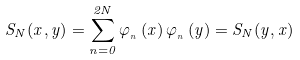Convert formula to latex. <formula><loc_0><loc_0><loc_500><loc_500>S _ { N } ( x , y ) = \sum _ { n = 0 } ^ { 2 N } \varphi _ { _ { n } } \left ( x \right ) \varphi _ { _ { n } } \left ( y \right ) = S _ { N } ( y , x )</formula> 